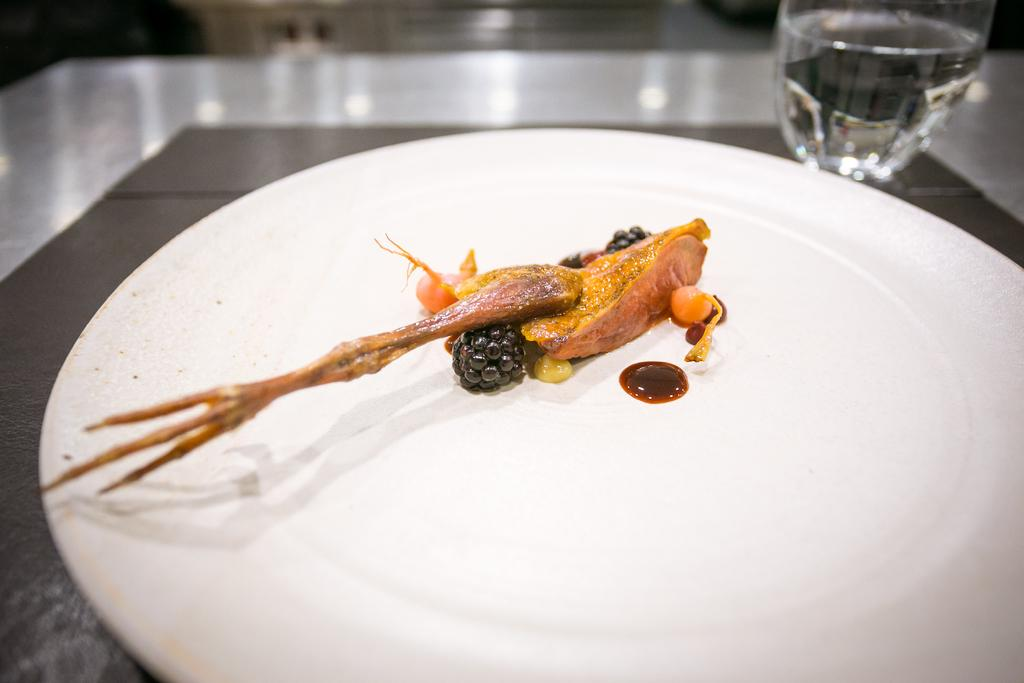What piece of furniture is present in the image? There is a table in the image. What is placed on the table? There is a plate and a glass of water on the table. What is in the plate? There is food in the plate. Can you describe the background of the image? The background of the image is blurry. What type of cloth is hanging from the tree in the image? There is no cloth or tree present in the image. What type of work is being done in the image? There is no work being done in the image; it only shows a table with a plate, glass of water, and food. 